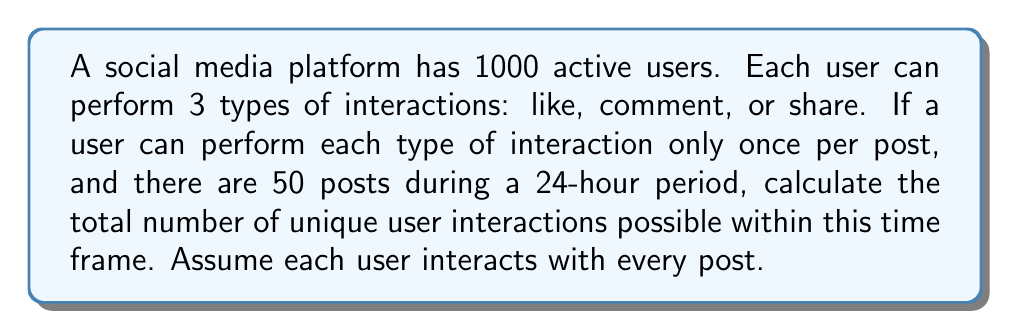Could you help me with this problem? Let's break this down step-by-step:

1) First, let's consider the number of interactions per user per post:
   - Each user can like once
   - Each user can comment once
   - Each user can share once
   So, there are 3 possible interactions per user per post.

2) Now, let's calculate the number of interactions per user across all posts:
   $$ \text{Interactions per user} = 3 \times 50 = 150 $$

3) To get the total number of unique interactions for all users:
   $$ \text{Total interactions} = \text{Interactions per user} \times \text{Number of users} $$
   $$ \text{Total interactions} = 150 \times 1000 = 150,000 $$

Therefore, the total number of unique user interactions possible within the 24-hour time frame is 150,000.
Answer: 150,000 